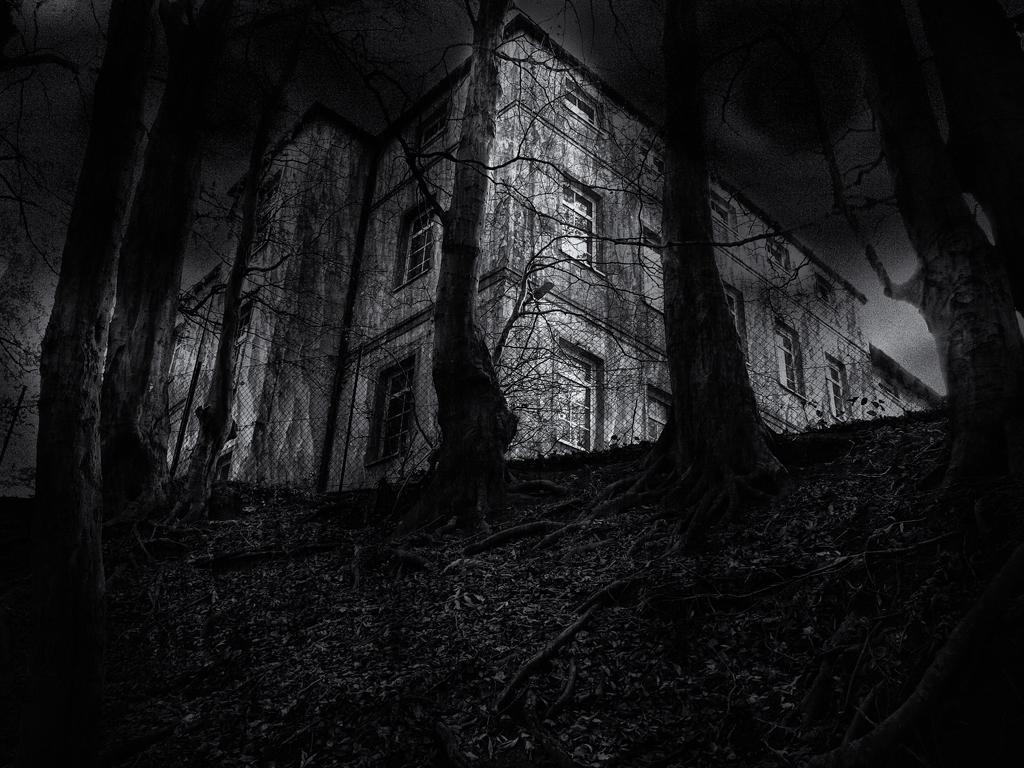Please provide a concise description of this image. In this picture we can see some dry trees in the front. Behind there is a building with some windows. On the top we can see the dark sky. 